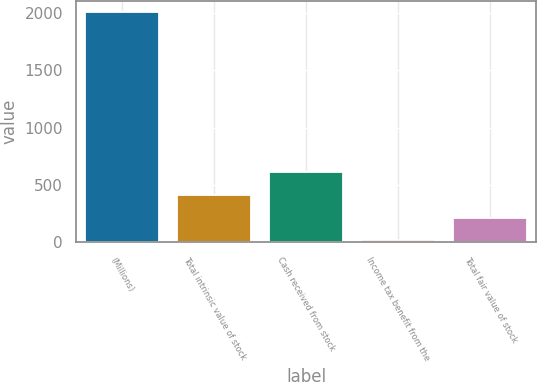<chart> <loc_0><loc_0><loc_500><loc_500><bar_chart><fcel>(Millions)<fcel>Total intrinsic value of stock<fcel>Cash received from stock<fcel>Income tax benefit from the<fcel>Total fair value of stock<nl><fcel>2007<fcel>415<fcel>614<fcel>17<fcel>216<nl></chart> 